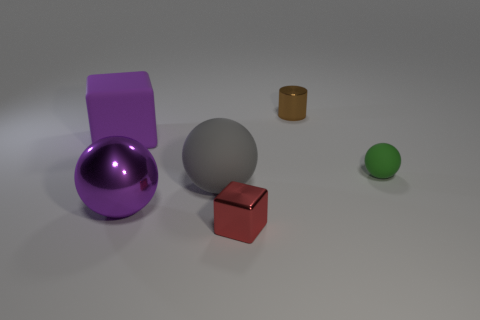Add 4 big brown cubes. How many objects exist? 10 Subtract all cylinders. How many objects are left? 5 Subtract all purple spheres. Subtract all purple rubber blocks. How many objects are left? 4 Add 1 big purple spheres. How many big purple spheres are left? 2 Add 4 blue objects. How many blue objects exist? 4 Subtract 0 blue balls. How many objects are left? 6 